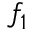<formula> <loc_0><loc_0><loc_500><loc_500>f _ { 1 }</formula> 